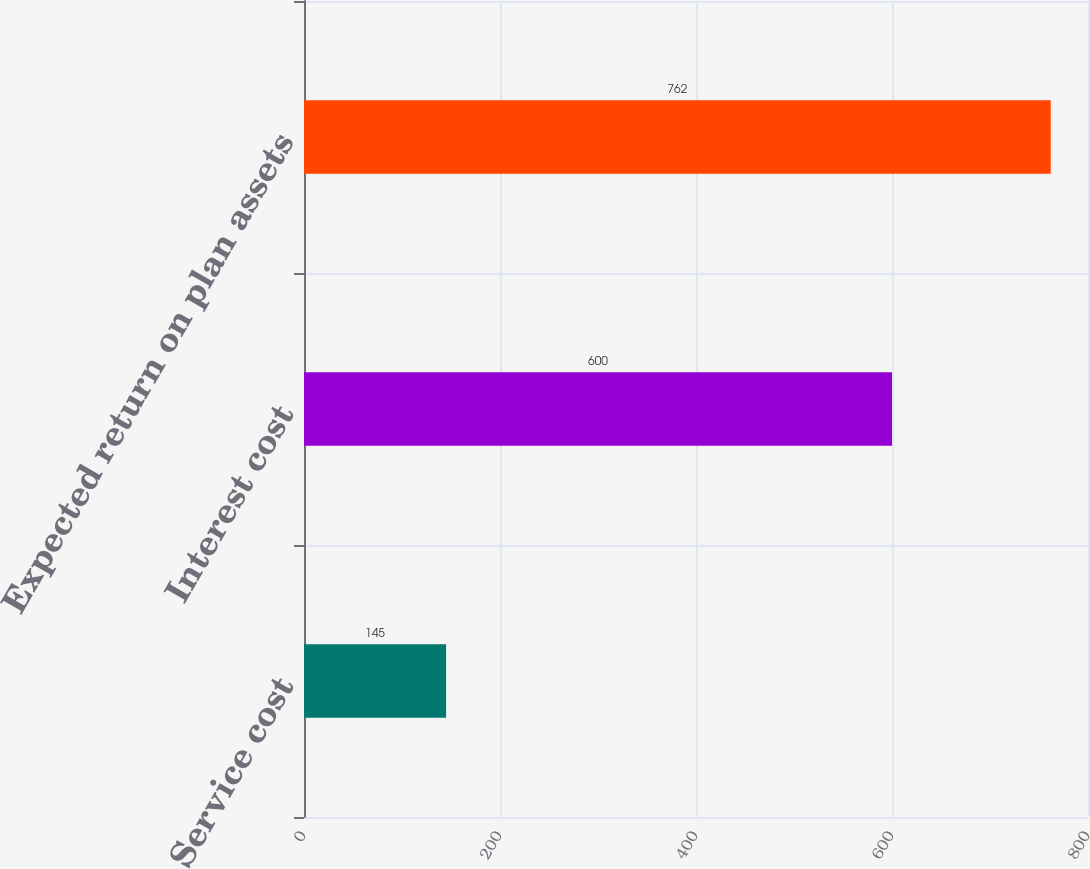<chart> <loc_0><loc_0><loc_500><loc_500><bar_chart><fcel>Service cost<fcel>Interest cost<fcel>Expected return on plan assets<nl><fcel>145<fcel>600<fcel>762<nl></chart> 